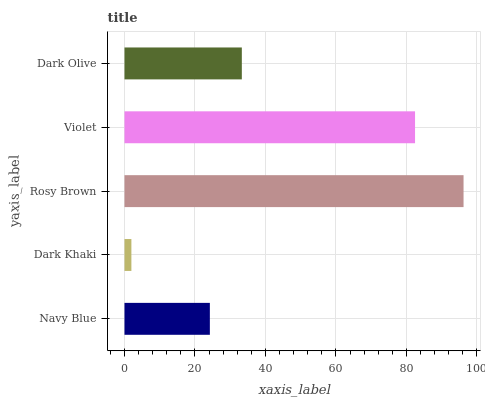Is Dark Khaki the minimum?
Answer yes or no. Yes. Is Rosy Brown the maximum?
Answer yes or no. Yes. Is Rosy Brown the minimum?
Answer yes or no. No. Is Dark Khaki the maximum?
Answer yes or no. No. Is Rosy Brown greater than Dark Khaki?
Answer yes or no. Yes. Is Dark Khaki less than Rosy Brown?
Answer yes or no. Yes. Is Dark Khaki greater than Rosy Brown?
Answer yes or no. No. Is Rosy Brown less than Dark Khaki?
Answer yes or no. No. Is Dark Olive the high median?
Answer yes or no. Yes. Is Dark Olive the low median?
Answer yes or no. Yes. Is Dark Khaki the high median?
Answer yes or no. No. Is Rosy Brown the low median?
Answer yes or no. No. 